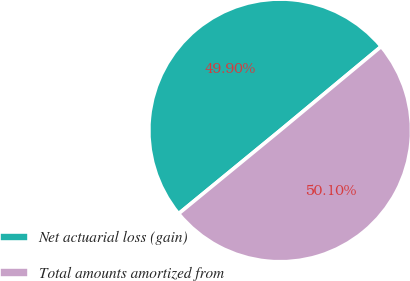Convert chart to OTSL. <chart><loc_0><loc_0><loc_500><loc_500><pie_chart><fcel>Net actuarial loss (gain)<fcel>Total amounts amortized from<nl><fcel>49.9%<fcel>50.1%<nl></chart> 